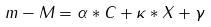Convert formula to latex. <formula><loc_0><loc_0><loc_500><loc_500>m - M = \alpha * C + \kappa * X + \gamma</formula> 